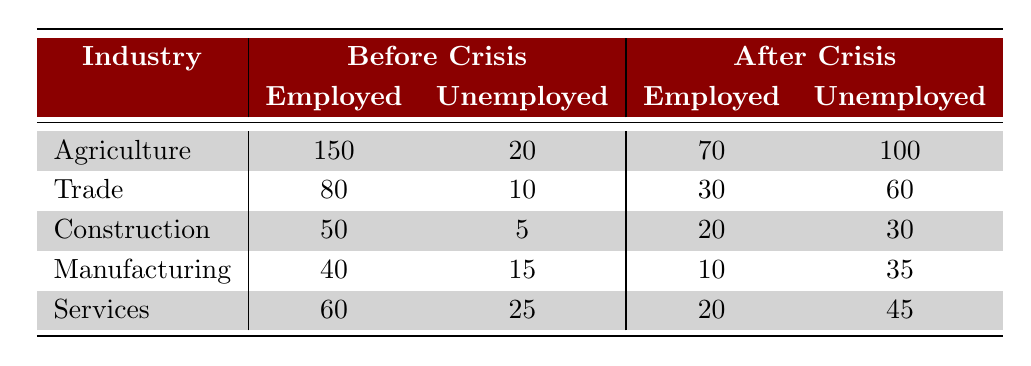What was the total number of employed individuals in Agriculture before the crisis? The table indicates that there were 150 employed individuals in Agriculture before the crisis.
Answer: 150 How many individuals were unemployed in the Trade industry after the crisis? The table shows that there were 60 unemployed individuals in the Trade industry after the crisis.
Answer: 60 What was the change in the number of employed individuals in the Construction industry from before to after the crisis? Before the crisis, there were 50 employed individuals in Construction, which decreased to 20 after the crisis. The change is 50 - 20 = 30.
Answer: 30 Did the number of unemployed individuals in the Manufacturing industry increase after the crisis? The table shows 15 unemployed in Manufacturing before the crisis and 35 after the crisis, indicating an increase.
Answer: Yes Which industry saw the largest increase in unemployment after the crisis? To find this, we look at the unemployment numbers after the crisis: Agriculture had 100, Trade had 60, Construction had 30, Manufacturing had 35, and Services had 45. The largest increase is in Agriculture, where the unemployment rose to 100.
Answer: Agriculture What is the total number of employed individuals across all industries before the crisis? Summing employed across all industries: 150 (Agriculture) + 80 (Trade) + 50 (Construction) + 40 (Manufacturing) + 60 (Services) = 380.
Answer: 380 What was the unemployment rate in the Services industry before the crisis? Before the crisis, there were 25 unemployed in Services out of a total of 85 (60 employed + 25 unemployed), which gives a rate of (25/85) * 100 = approximately 29.41%.
Answer: 29.41% How many more unemployed individuals were there in the Agriculture industry after the crisis compared to before? Before the crisis, there were 20 unemployed in Agriculture. After the crisis, it rose to 100. The difference is 100 - 20 = 80.
Answer: 80 Which industry faced the highest percentage decrease in employed individuals from before to after the crisis? Calculating the decrease percentage for each: Agriculture: (150-70)/150 * 100 = 53.33%, Trade: (80-30)/80 * 100 = 62.5%, Construction: (50-20)/50 * 100 = 60%, Manufacturing: (40-10)/40 * 100 = 75%, Services: (60-20)/60 * 100 = 66.67%. The highest percentage decrease is in Manufacturing with 75%.
Answer: Manufacturing 